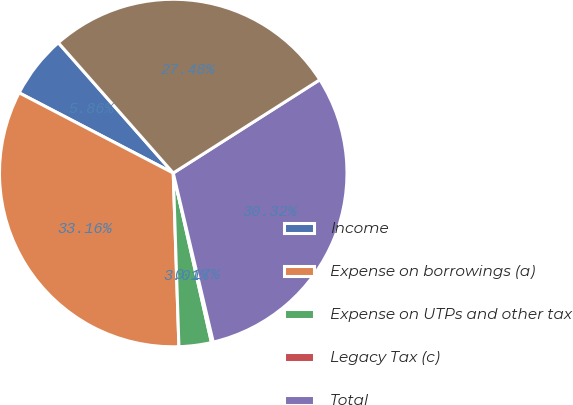Convert chart. <chart><loc_0><loc_0><loc_500><loc_500><pie_chart><fcel>Income<fcel>Expense on borrowings (a)<fcel>Expense on UTPs and other tax<fcel>Legacy Tax (c)<fcel>Total<fcel>Interest paid (d)<nl><fcel>5.86%<fcel>33.16%<fcel>3.01%<fcel>0.17%<fcel>30.32%<fcel>27.48%<nl></chart> 